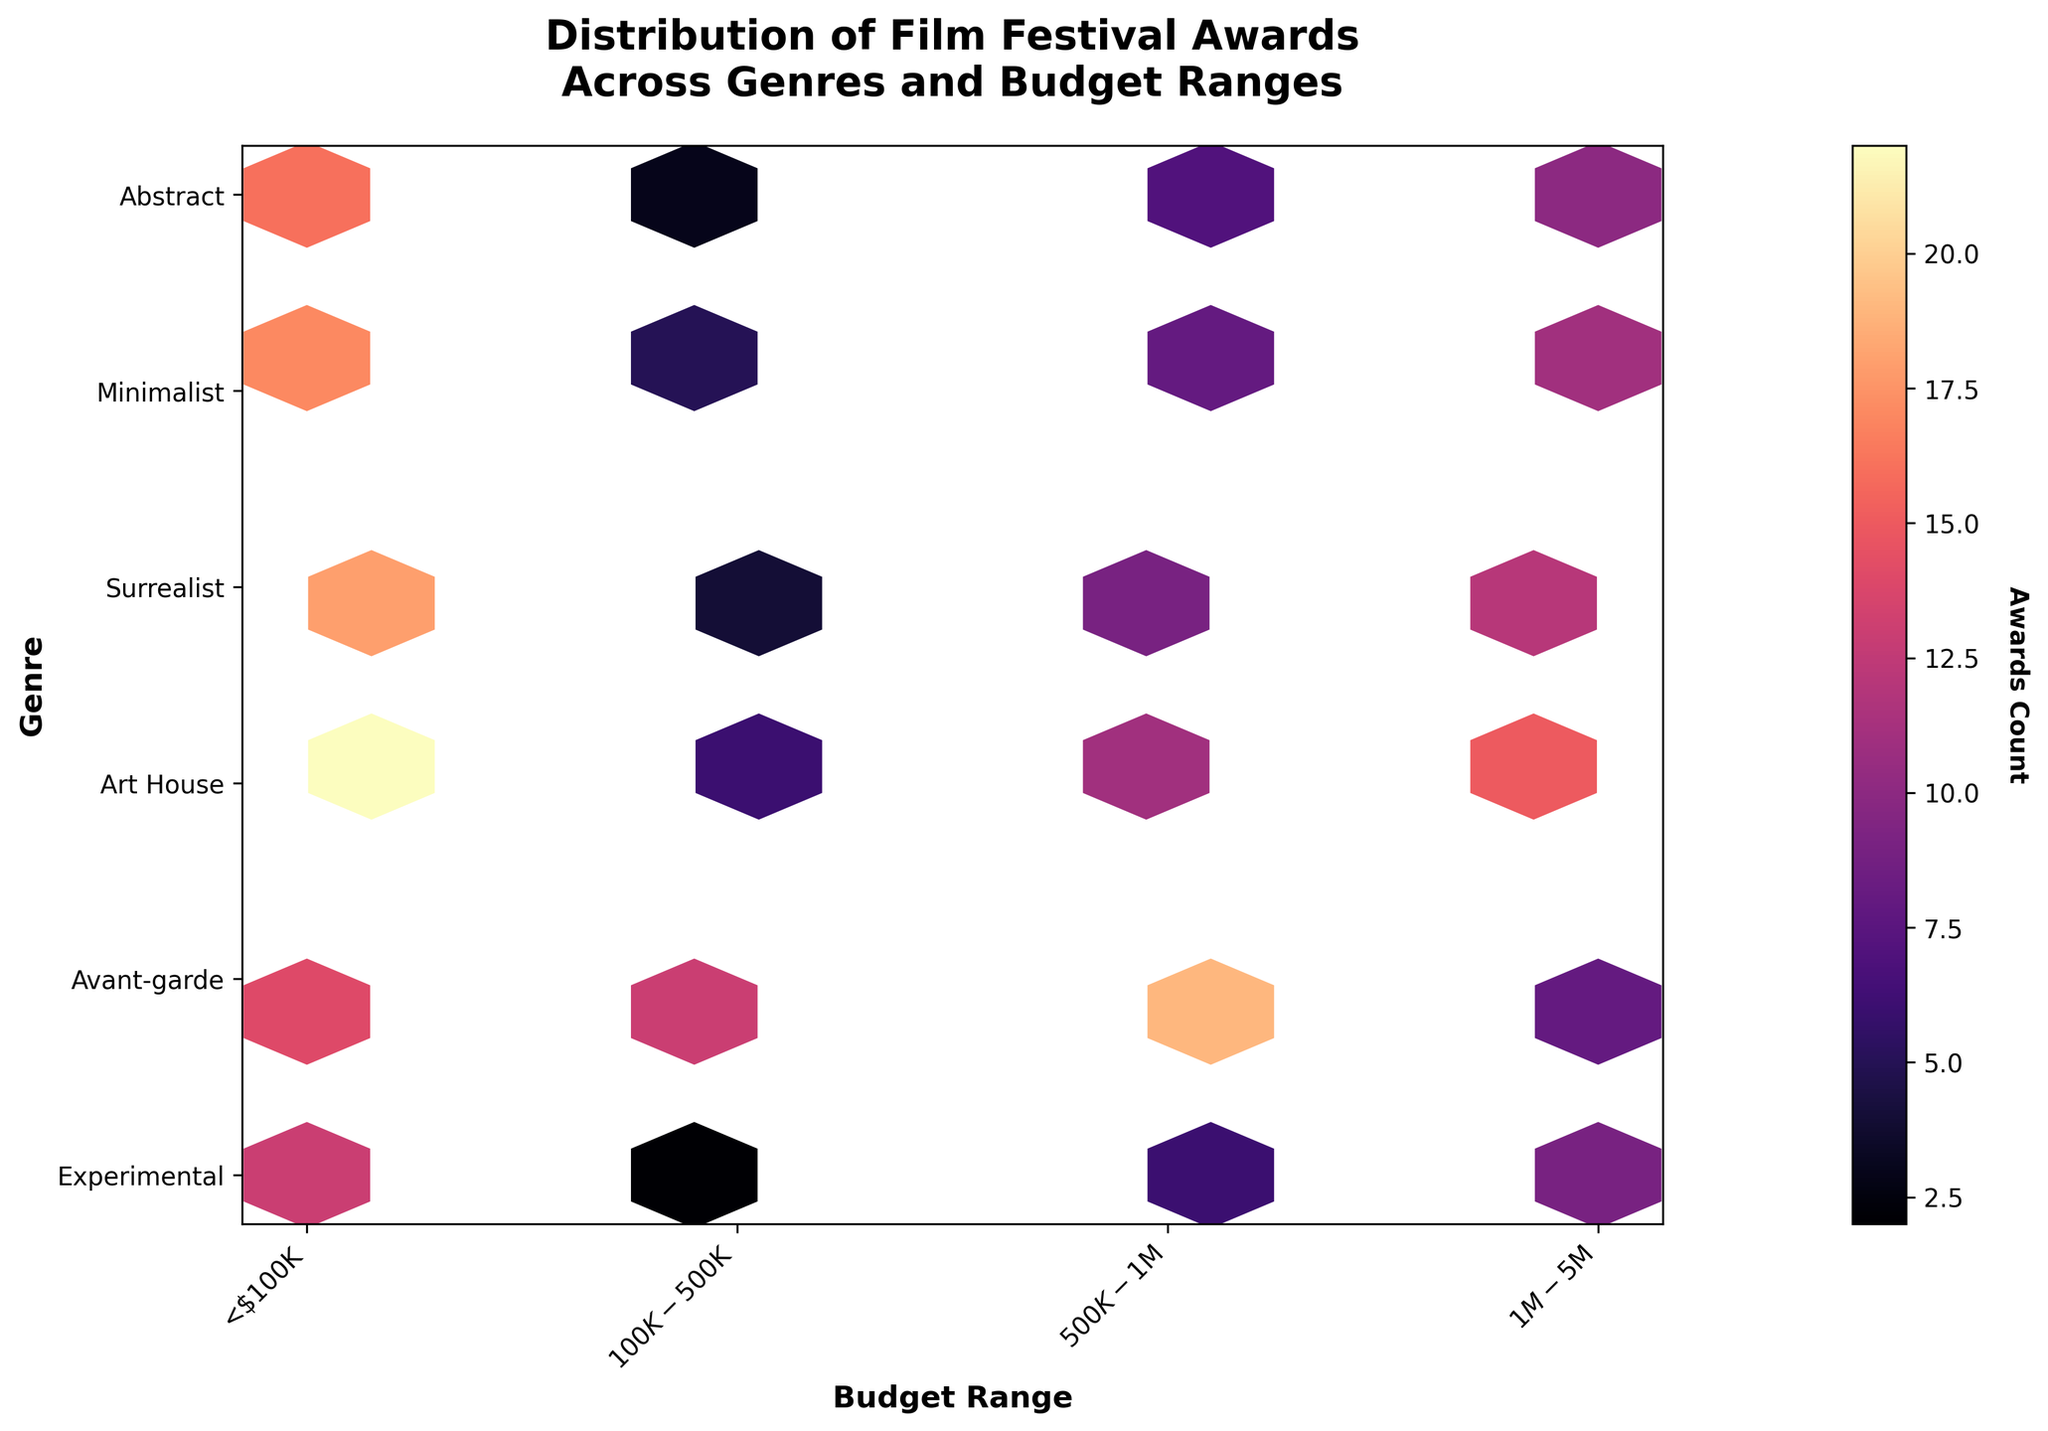What's the title of the plot? The title is usually found at the top center of the plot. In this case, it reads "Distribution of Film Festival Awards Across Genres and Budget Ranges".
Answer: Distribution of Film Festival Awards Across Genres and Budget Ranges Which genre has the highest number of awards in the $100K-$500K budget range? To find this, look for the hexbin with the highest color intensity in the $100K-$500K budget range on the x-axis and match it with the corresponding genre on the y-axis. The genre "Avant-garde" has the highest intensity in this range.
Answer: Avant-garde How do award counts in the <$100K budget range compare across genres? Observe the hexbin colors for all genres in the <$100K budget range. "Avant-garde" has the highest awards (15), and "Art House" has the fewest (8).
Answer: "Avant-garde" has the highest, "Art House" has the fewest What is the average number of awards for Minimalist films across all budget ranges? To calculate the average, sum the awards for Minimalist in each budget range: 11 (<$100K) + 17 ($100K-$500K) + 8 ($500K-$1M) + 5 ($1M-$5M) = 41. Then divide by the number of ranges: 41/4 = 10.25.
Answer: 10.25 Which budget range has the highest concentration of awards across all genres? Look for the hexbin column with the most intense colors across all rows (genres). The $100K-$500K range appears to have the highest concentrations.
Answer: $100K-$500K Are there any budget ranges where no genre has more than 10 awards? Scan each budget range to identify hexbin colors indicating fewer awards. The $1M-$5M budget range has no genre exceeding 10 awards.
Answer: $1M-$5M How do the awards count for Experimental films in the $500K-$1M range compare to those for Art House films in the same range? Compare the hexbin colors corresponding to the $500K-$1M range for both Experimental and Art House genres on the y-axis. Experimental has 9 awards, while Art House has 19.
Answer: Art House has more What's the range with the least variation in awards counts? Identify the budget range where hexbin colors show the least contrast. The <$100K budget range has relatively similar color intensities across genres, indicating less variation.
Answer: <$100K What genre-budget combination has the lowest award count? Look for the hexbin with the least intense color. Abstract genre in the $1M-$5M budget range has an award count of 2.
Answer: Abstract in the $1M-$5M range Which genre has the most evenly distributed awards across all budget ranges? Check which genre has the most similar color intensities in its hexbin row across all budget ranges. The Experimental genre has relatively even colors, indicating an even distribution.
Answer: Experimental 